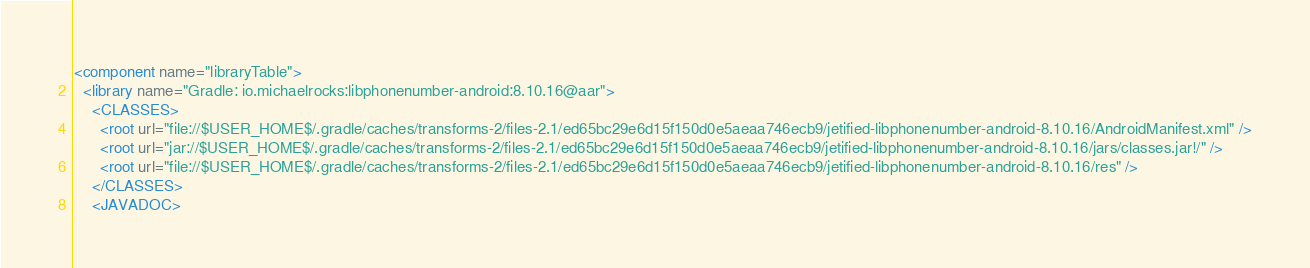Convert code to text. <code><loc_0><loc_0><loc_500><loc_500><_XML_><component name="libraryTable">
  <library name="Gradle: io.michaelrocks:libphonenumber-android:8.10.16@aar">
    <CLASSES>
      <root url="file://$USER_HOME$/.gradle/caches/transforms-2/files-2.1/ed65bc29e6d15f150d0e5aeaa746ecb9/jetified-libphonenumber-android-8.10.16/AndroidManifest.xml" />
      <root url="jar://$USER_HOME$/.gradle/caches/transforms-2/files-2.1/ed65bc29e6d15f150d0e5aeaa746ecb9/jetified-libphonenumber-android-8.10.16/jars/classes.jar!/" />
      <root url="file://$USER_HOME$/.gradle/caches/transforms-2/files-2.1/ed65bc29e6d15f150d0e5aeaa746ecb9/jetified-libphonenumber-android-8.10.16/res" />
    </CLASSES>
    <JAVADOC></code> 